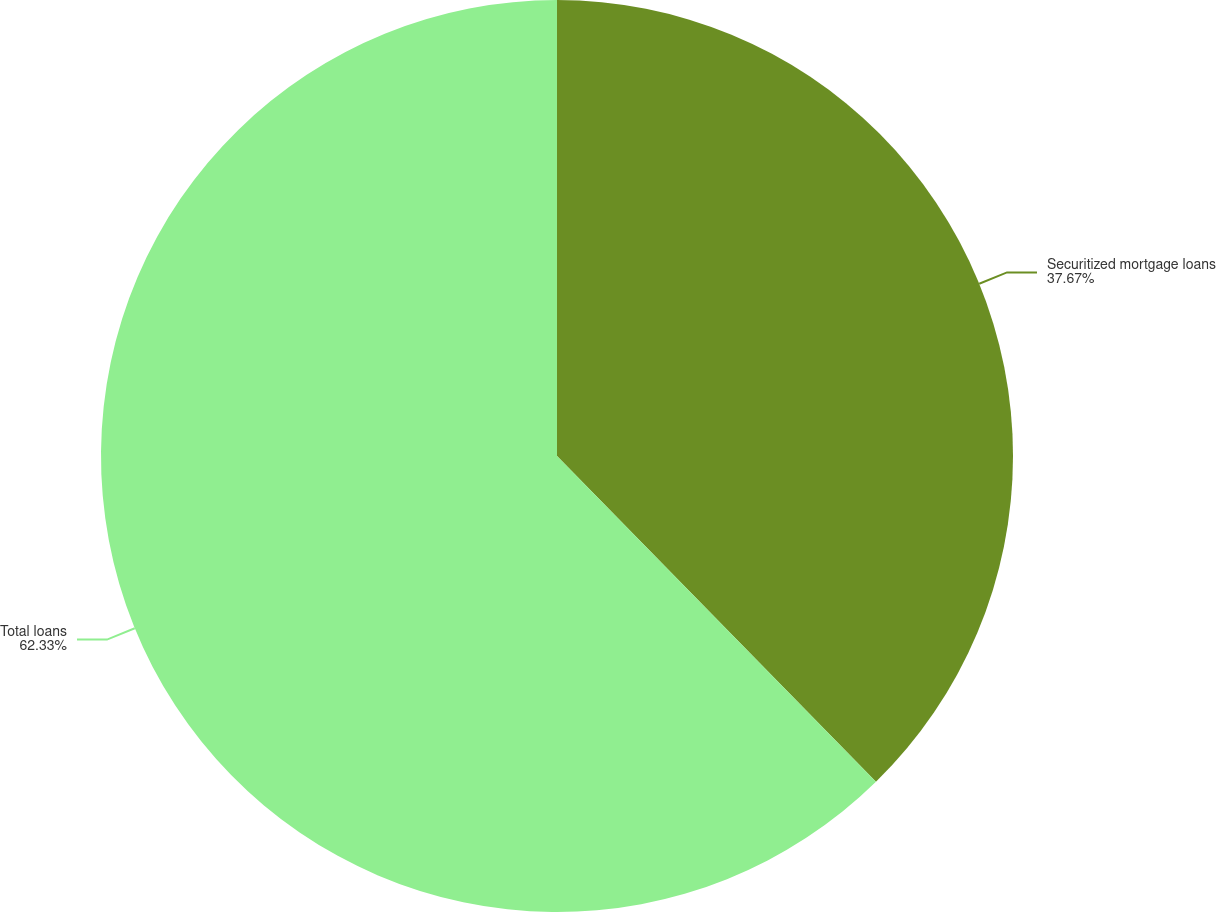Convert chart to OTSL. <chart><loc_0><loc_0><loc_500><loc_500><pie_chart><fcel>Securitized mortgage loans<fcel>Total loans<nl><fcel>37.67%<fcel>62.33%<nl></chart> 